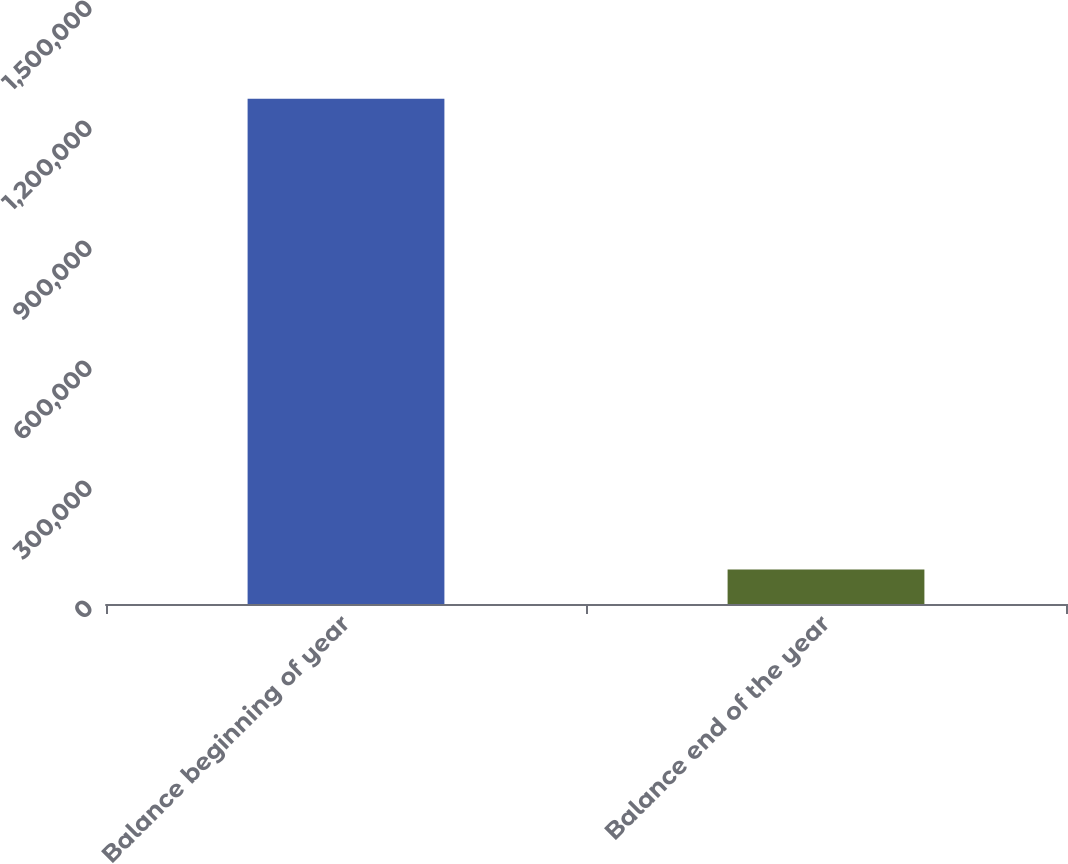Convert chart. <chart><loc_0><loc_0><loc_500><loc_500><bar_chart><fcel>Balance beginning of year<fcel>Balance end of the year<nl><fcel>1.26292e+06<fcel>86353<nl></chart> 